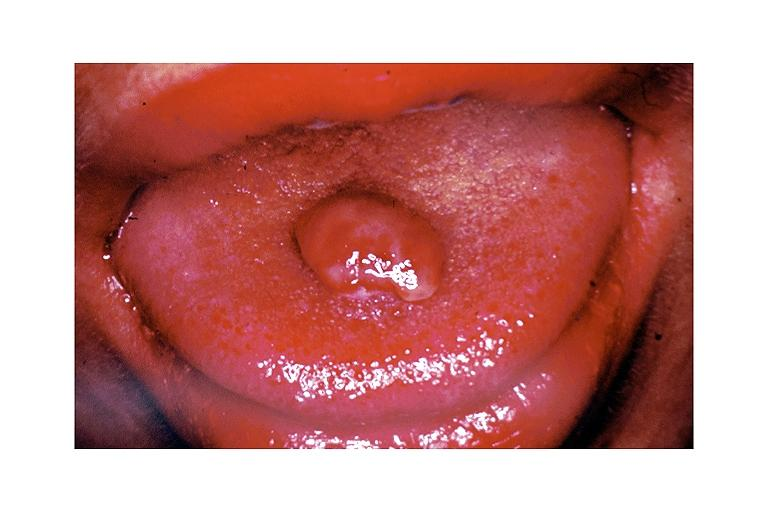what is present?
Answer the question using a single word or phrase. Oral 